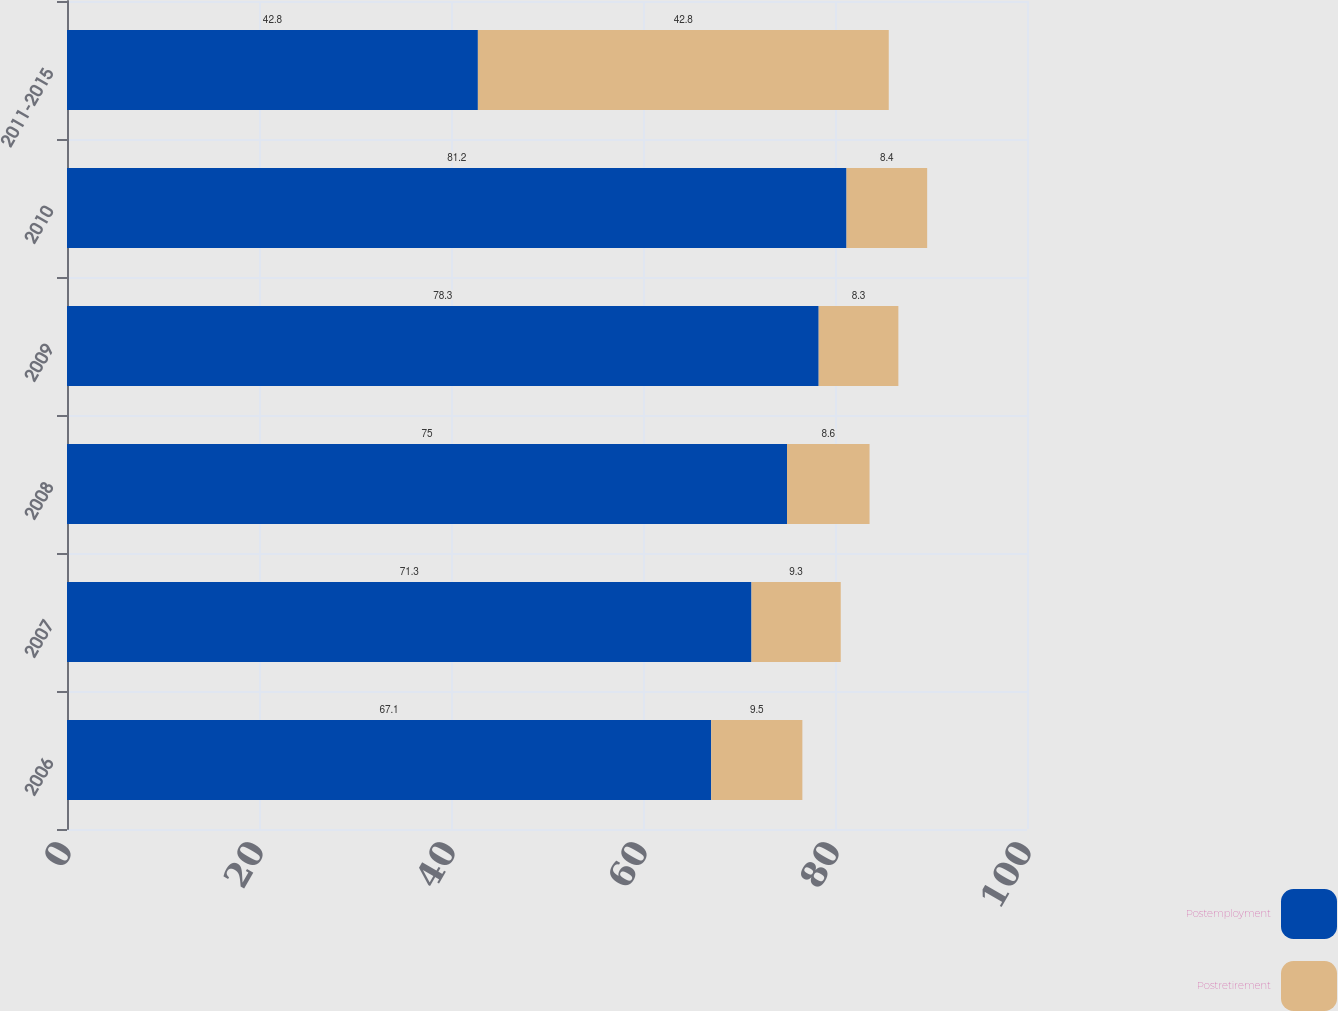<chart> <loc_0><loc_0><loc_500><loc_500><stacked_bar_chart><ecel><fcel>2006<fcel>2007<fcel>2008<fcel>2009<fcel>2010<fcel>2011-2015<nl><fcel>Postemployment<fcel>67.1<fcel>71.3<fcel>75<fcel>78.3<fcel>81.2<fcel>42.8<nl><fcel>Postretirement<fcel>9.5<fcel>9.3<fcel>8.6<fcel>8.3<fcel>8.4<fcel>42.8<nl></chart> 